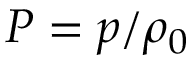<formula> <loc_0><loc_0><loc_500><loc_500>P = p / \rho _ { 0 }</formula> 